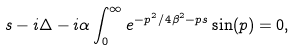<formula> <loc_0><loc_0><loc_500><loc_500>s - i \Delta - i \alpha \int _ { 0 } ^ { \infty } e ^ { - p ^ { 2 } / 4 \beta ^ { 2 } - p s } \sin ( p ) = 0 ,</formula> 